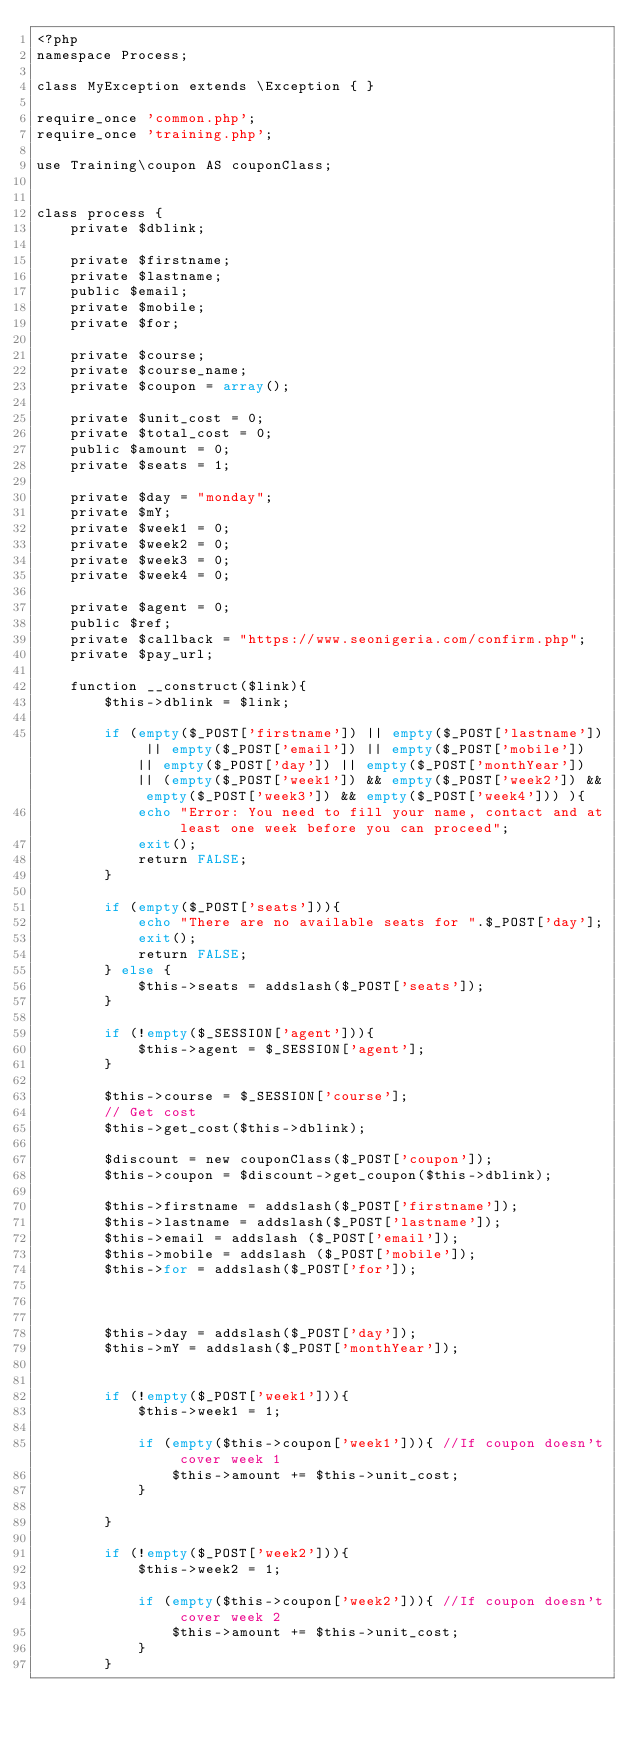<code> <loc_0><loc_0><loc_500><loc_500><_PHP_><?php
namespace Process;

class MyException extends \Exception { }

require_once 'common.php';
require_once 'training.php';

use Training\coupon AS couponClass;


class process {
    private $dblink;
    
    private $firstname;
    private $lastname;
    public $email;
    private $mobile;
    private $for;
    
    private $course;
    private $course_name;
    private $coupon = array();

    private $unit_cost = 0;
    private $total_cost = 0;
    public $amount = 0;
    private $seats = 1;

    private $day = "monday";
    private $mY;
    private $week1 = 0;
    private $week2 = 0;
    private $week3 = 0;
    private $week4 = 0;

    private $agent = 0;
    public $ref;
    private $callback = "https://www.seonigeria.com/confirm.php";
    private $pay_url;

    function __construct($link){
        $this->dblink = $link;

        if (empty($_POST['firstname']) || empty($_POST['lastname']) || empty($_POST['email']) || empty($_POST['mobile']) || empty($_POST['day']) || empty($_POST['monthYear']) || (empty($_POST['week1']) && empty($_POST['week2']) && empty($_POST['week3']) && empty($_POST['week4'])) ){
            echo "Error: You need to fill your name, contact and at least one week before you can proceed";
            exit();
            return FALSE;
        }

        if (empty($_POST['seats'])){
            echo "There are no available seats for ".$_POST['day'];
            exit();
            return FALSE;
        } else {
            $this->seats = addslash($_POST['seats']);
        }

        if (!empty($_SESSION['agent'])){
            $this->agent = $_SESSION['agent'];
        }

        $this->course = $_SESSION['course'];
        // Get cost
        $this->get_cost($this->dblink);

        $discount = new couponClass($_POST['coupon']);
        $this->coupon = $discount->get_coupon($this->dblink);

        $this->firstname = addslash($_POST['firstname']);
        $this->lastname = addslash($_POST['lastname']);
        $this->email = addslash ($_POST['email']);
        $this->mobile = addslash ($_POST['mobile']);
        $this->for = addslash($_POST['for']);
        


        $this->day = addslash($_POST['day']);
        $this->mY = addslash($_POST['monthYear']);


        if (!empty($_POST['week1'])){
            $this->week1 = 1;

            if (empty($this->coupon['week1'])){ //If coupon doesn't cover week 1
                $this->amount += $this->unit_cost;
            }
            
        }

        if (!empty($_POST['week2'])){
            $this->week2 = 1;
            
            if (empty($this->coupon['week2'])){ //If coupon doesn't cover week 2
                $this->amount += $this->unit_cost;
            }
        }
</code> 